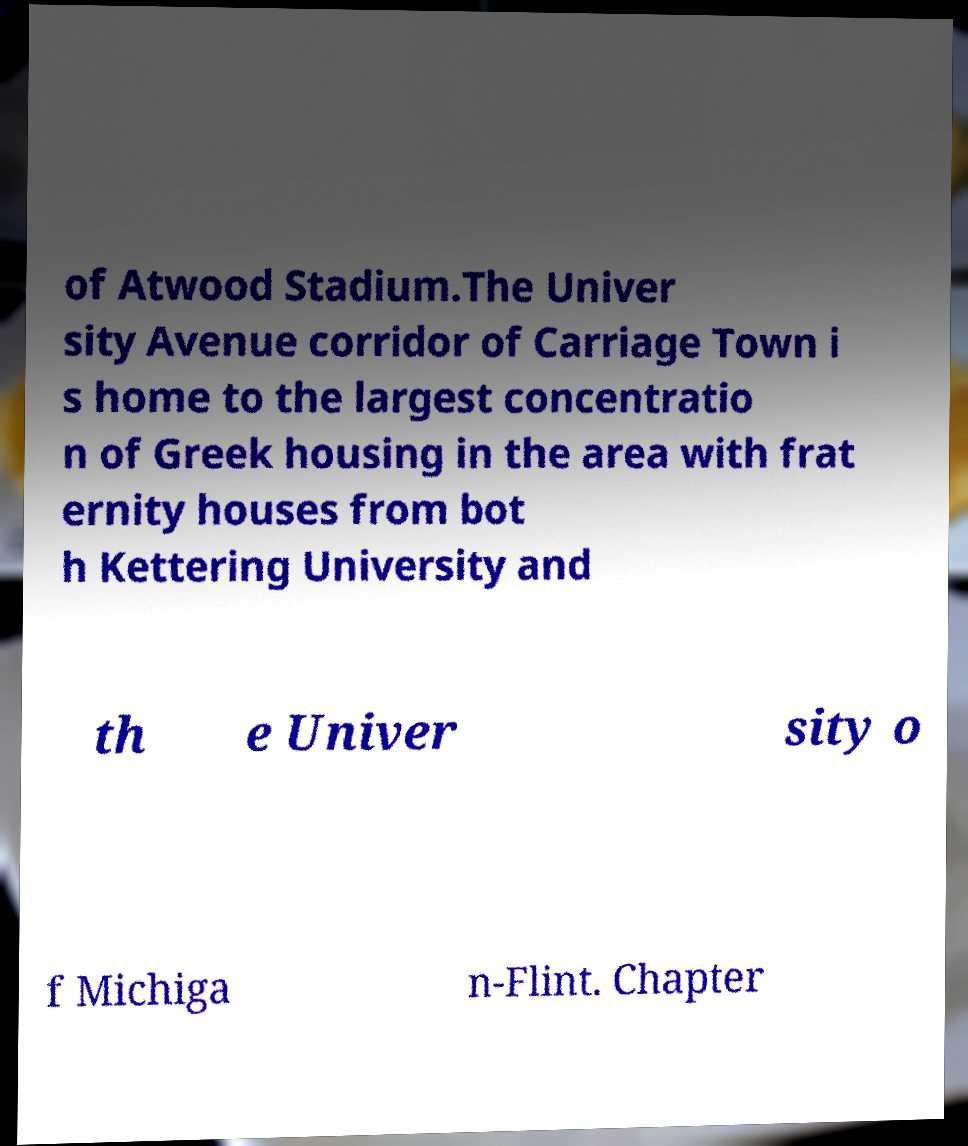I need the written content from this picture converted into text. Can you do that? of Atwood Stadium.The Univer sity Avenue corridor of Carriage Town i s home to the largest concentratio n of Greek housing in the area with frat ernity houses from bot h Kettering University and th e Univer sity o f Michiga n-Flint. Chapter 